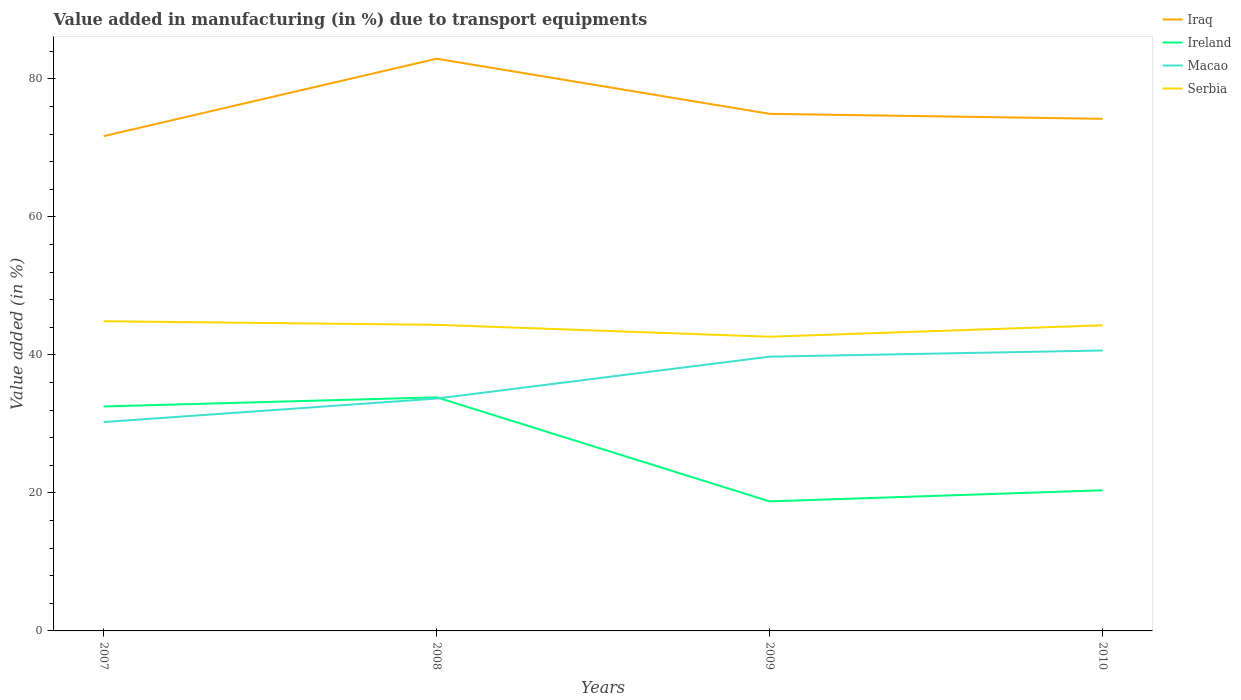How many different coloured lines are there?
Offer a terse response. 4. Is the number of lines equal to the number of legend labels?
Provide a succinct answer. Yes. Across all years, what is the maximum percentage of value added in manufacturing due to transport equipments in Macao?
Your answer should be very brief. 30.27. What is the total percentage of value added in manufacturing due to transport equipments in Ireland in the graph?
Provide a short and direct response. 15.08. What is the difference between the highest and the second highest percentage of value added in manufacturing due to transport equipments in Iraq?
Offer a terse response. 11.22. What is the difference between the highest and the lowest percentage of value added in manufacturing due to transport equipments in Macao?
Keep it short and to the point. 2. Is the percentage of value added in manufacturing due to transport equipments in Ireland strictly greater than the percentage of value added in manufacturing due to transport equipments in Serbia over the years?
Provide a short and direct response. Yes. How many lines are there?
Make the answer very short. 4. What is the difference between two consecutive major ticks on the Y-axis?
Your answer should be very brief. 20. Does the graph contain any zero values?
Ensure brevity in your answer.  No. Does the graph contain grids?
Offer a terse response. No. Where does the legend appear in the graph?
Give a very brief answer. Top right. How are the legend labels stacked?
Offer a terse response. Vertical. What is the title of the graph?
Ensure brevity in your answer.  Value added in manufacturing (in %) due to transport equipments. What is the label or title of the Y-axis?
Your answer should be compact. Value added (in %). What is the Value added (in %) of Iraq in 2007?
Your response must be concise. 71.71. What is the Value added (in %) of Ireland in 2007?
Provide a succinct answer. 32.53. What is the Value added (in %) of Macao in 2007?
Make the answer very short. 30.27. What is the Value added (in %) in Serbia in 2007?
Offer a terse response. 44.88. What is the Value added (in %) of Iraq in 2008?
Your answer should be compact. 82.93. What is the Value added (in %) in Ireland in 2008?
Your answer should be very brief. 33.86. What is the Value added (in %) of Macao in 2008?
Make the answer very short. 33.68. What is the Value added (in %) of Serbia in 2008?
Your answer should be very brief. 44.37. What is the Value added (in %) of Iraq in 2009?
Make the answer very short. 74.94. What is the Value added (in %) in Ireland in 2009?
Offer a very short reply. 18.77. What is the Value added (in %) of Macao in 2009?
Your answer should be compact. 39.75. What is the Value added (in %) of Serbia in 2009?
Offer a very short reply. 42.64. What is the Value added (in %) of Iraq in 2010?
Offer a very short reply. 74.22. What is the Value added (in %) of Ireland in 2010?
Your answer should be very brief. 20.38. What is the Value added (in %) in Macao in 2010?
Give a very brief answer. 40.65. What is the Value added (in %) of Serbia in 2010?
Provide a succinct answer. 44.29. Across all years, what is the maximum Value added (in %) of Iraq?
Provide a short and direct response. 82.93. Across all years, what is the maximum Value added (in %) of Ireland?
Your answer should be very brief. 33.86. Across all years, what is the maximum Value added (in %) of Macao?
Your answer should be very brief. 40.65. Across all years, what is the maximum Value added (in %) of Serbia?
Your answer should be compact. 44.88. Across all years, what is the minimum Value added (in %) in Iraq?
Ensure brevity in your answer.  71.71. Across all years, what is the minimum Value added (in %) of Ireland?
Offer a terse response. 18.77. Across all years, what is the minimum Value added (in %) in Macao?
Offer a very short reply. 30.27. Across all years, what is the minimum Value added (in %) in Serbia?
Keep it short and to the point. 42.64. What is the total Value added (in %) in Iraq in the graph?
Your response must be concise. 303.81. What is the total Value added (in %) of Ireland in the graph?
Offer a terse response. 105.54. What is the total Value added (in %) of Macao in the graph?
Provide a short and direct response. 144.35. What is the total Value added (in %) in Serbia in the graph?
Keep it short and to the point. 176.18. What is the difference between the Value added (in %) of Iraq in 2007 and that in 2008?
Ensure brevity in your answer.  -11.22. What is the difference between the Value added (in %) of Ireland in 2007 and that in 2008?
Keep it short and to the point. -1.32. What is the difference between the Value added (in %) in Macao in 2007 and that in 2008?
Your answer should be compact. -3.41. What is the difference between the Value added (in %) in Serbia in 2007 and that in 2008?
Your answer should be compact. 0.51. What is the difference between the Value added (in %) in Iraq in 2007 and that in 2009?
Your answer should be very brief. -3.23. What is the difference between the Value added (in %) in Ireland in 2007 and that in 2009?
Your response must be concise. 13.76. What is the difference between the Value added (in %) in Macao in 2007 and that in 2009?
Provide a short and direct response. -9.48. What is the difference between the Value added (in %) in Serbia in 2007 and that in 2009?
Make the answer very short. 2.24. What is the difference between the Value added (in %) in Iraq in 2007 and that in 2010?
Your answer should be compact. -2.51. What is the difference between the Value added (in %) of Ireland in 2007 and that in 2010?
Provide a succinct answer. 12.15. What is the difference between the Value added (in %) of Macao in 2007 and that in 2010?
Keep it short and to the point. -10.38. What is the difference between the Value added (in %) of Serbia in 2007 and that in 2010?
Your answer should be compact. 0.59. What is the difference between the Value added (in %) in Iraq in 2008 and that in 2009?
Your answer should be very brief. 7.99. What is the difference between the Value added (in %) in Ireland in 2008 and that in 2009?
Offer a very short reply. 15.08. What is the difference between the Value added (in %) of Macao in 2008 and that in 2009?
Provide a succinct answer. -6.07. What is the difference between the Value added (in %) in Serbia in 2008 and that in 2009?
Offer a very short reply. 1.73. What is the difference between the Value added (in %) of Iraq in 2008 and that in 2010?
Ensure brevity in your answer.  8.71. What is the difference between the Value added (in %) of Ireland in 2008 and that in 2010?
Offer a terse response. 13.47. What is the difference between the Value added (in %) in Macao in 2008 and that in 2010?
Provide a succinct answer. -6.97. What is the difference between the Value added (in %) in Serbia in 2008 and that in 2010?
Make the answer very short. 0.07. What is the difference between the Value added (in %) in Iraq in 2009 and that in 2010?
Your answer should be compact. 0.72. What is the difference between the Value added (in %) in Ireland in 2009 and that in 2010?
Ensure brevity in your answer.  -1.61. What is the difference between the Value added (in %) in Macao in 2009 and that in 2010?
Your answer should be very brief. -0.9. What is the difference between the Value added (in %) in Serbia in 2009 and that in 2010?
Offer a very short reply. -1.66. What is the difference between the Value added (in %) of Iraq in 2007 and the Value added (in %) of Ireland in 2008?
Offer a terse response. 37.86. What is the difference between the Value added (in %) of Iraq in 2007 and the Value added (in %) of Macao in 2008?
Offer a terse response. 38.03. What is the difference between the Value added (in %) in Iraq in 2007 and the Value added (in %) in Serbia in 2008?
Give a very brief answer. 27.35. What is the difference between the Value added (in %) of Ireland in 2007 and the Value added (in %) of Macao in 2008?
Your answer should be compact. -1.15. What is the difference between the Value added (in %) in Ireland in 2007 and the Value added (in %) in Serbia in 2008?
Your answer should be compact. -11.83. What is the difference between the Value added (in %) in Macao in 2007 and the Value added (in %) in Serbia in 2008?
Your response must be concise. -14.1. What is the difference between the Value added (in %) of Iraq in 2007 and the Value added (in %) of Ireland in 2009?
Provide a short and direct response. 52.94. What is the difference between the Value added (in %) in Iraq in 2007 and the Value added (in %) in Macao in 2009?
Offer a terse response. 31.96. What is the difference between the Value added (in %) of Iraq in 2007 and the Value added (in %) of Serbia in 2009?
Offer a terse response. 29.07. What is the difference between the Value added (in %) in Ireland in 2007 and the Value added (in %) in Macao in 2009?
Your response must be concise. -7.22. What is the difference between the Value added (in %) in Ireland in 2007 and the Value added (in %) in Serbia in 2009?
Provide a short and direct response. -10.11. What is the difference between the Value added (in %) in Macao in 2007 and the Value added (in %) in Serbia in 2009?
Your response must be concise. -12.37. What is the difference between the Value added (in %) of Iraq in 2007 and the Value added (in %) of Ireland in 2010?
Provide a succinct answer. 51.33. What is the difference between the Value added (in %) of Iraq in 2007 and the Value added (in %) of Macao in 2010?
Provide a succinct answer. 31.07. What is the difference between the Value added (in %) of Iraq in 2007 and the Value added (in %) of Serbia in 2010?
Your response must be concise. 27.42. What is the difference between the Value added (in %) of Ireland in 2007 and the Value added (in %) of Macao in 2010?
Give a very brief answer. -8.11. What is the difference between the Value added (in %) of Ireland in 2007 and the Value added (in %) of Serbia in 2010?
Provide a succinct answer. -11.76. What is the difference between the Value added (in %) in Macao in 2007 and the Value added (in %) in Serbia in 2010?
Give a very brief answer. -14.02. What is the difference between the Value added (in %) in Iraq in 2008 and the Value added (in %) in Ireland in 2009?
Your answer should be compact. 64.16. What is the difference between the Value added (in %) of Iraq in 2008 and the Value added (in %) of Macao in 2009?
Make the answer very short. 43.18. What is the difference between the Value added (in %) in Iraq in 2008 and the Value added (in %) in Serbia in 2009?
Your answer should be compact. 40.29. What is the difference between the Value added (in %) in Ireland in 2008 and the Value added (in %) in Macao in 2009?
Offer a very short reply. -5.89. What is the difference between the Value added (in %) in Ireland in 2008 and the Value added (in %) in Serbia in 2009?
Provide a short and direct response. -8.78. What is the difference between the Value added (in %) in Macao in 2008 and the Value added (in %) in Serbia in 2009?
Provide a succinct answer. -8.96. What is the difference between the Value added (in %) in Iraq in 2008 and the Value added (in %) in Ireland in 2010?
Provide a succinct answer. 62.55. What is the difference between the Value added (in %) of Iraq in 2008 and the Value added (in %) of Macao in 2010?
Offer a very short reply. 42.29. What is the difference between the Value added (in %) of Iraq in 2008 and the Value added (in %) of Serbia in 2010?
Keep it short and to the point. 38.64. What is the difference between the Value added (in %) of Ireland in 2008 and the Value added (in %) of Macao in 2010?
Your answer should be compact. -6.79. What is the difference between the Value added (in %) of Ireland in 2008 and the Value added (in %) of Serbia in 2010?
Ensure brevity in your answer.  -10.44. What is the difference between the Value added (in %) of Macao in 2008 and the Value added (in %) of Serbia in 2010?
Give a very brief answer. -10.61. What is the difference between the Value added (in %) of Iraq in 2009 and the Value added (in %) of Ireland in 2010?
Provide a short and direct response. 54.56. What is the difference between the Value added (in %) of Iraq in 2009 and the Value added (in %) of Macao in 2010?
Keep it short and to the point. 34.3. What is the difference between the Value added (in %) of Iraq in 2009 and the Value added (in %) of Serbia in 2010?
Your answer should be very brief. 30.65. What is the difference between the Value added (in %) in Ireland in 2009 and the Value added (in %) in Macao in 2010?
Your answer should be very brief. -21.87. What is the difference between the Value added (in %) in Ireland in 2009 and the Value added (in %) in Serbia in 2010?
Keep it short and to the point. -25.52. What is the difference between the Value added (in %) in Macao in 2009 and the Value added (in %) in Serbia in 2010?
Your answer should be very brief. -4.54. What is the average Value added (in %) of Iraq per year?
Make the answer very short. 75.95. What is the average Value added (in %) in Ireland per year?
Your answer should be very brief. 26.39. What is the average Value added (in %) in Macao per year?
Offer a terse response. 36.09. What is the average Value added (in %) in Serbia per year?
Ensure brevity in your answer.  44.04. In the year 2007, what is the difference between the Value added (in %) in Iraq and Value added (in %) in Ireland?
Offer a terse response. 39.18. In the year 2007, what is the difference between the Value added (in %) in Iraq and Value added (in %) in Macao?
Make the answer very short. 41.44. In the year 2007, what is the difference between the Value added (in %) in Iraq and Value added (in %) in Serbia?
Offer a terse response. 26.83. In the year 2007, what is the difference between the Value added (in %) of Ireland and Value added (in %) of Macao?
Your answer should be compact. 2.26. In the year 2007, what is the difference between the Value added (in %) of Ireland and Value added (in %) of Serbia?
Keep it short and to the point. -12.35. In the year 2007, what is the difference between the Value added (in %) of Macao and Value added (in %) of Serbia?
Give a very brief answer. -14.61. In the year 2008, what is the difference between the Value added (in %) in Iraq and Value added (in %) in Ireland?
Give a very brief answer. 49.08. In the year 2008, what is the difference between the Value added (in %) of Iraq and Value added (in %) of Macao?
Keep it short and to the point. 49.25. In the year 2008, what is the difference between the Value added (in %) of Iraq and Value added (in %) of Serbia?
Offer a terse response. 38.57. In the year 2008, what is the difference between the Value added (in %) of Ireland and Value added (in %) of Macao?
Your answer should be very brief. 0.18. In the year 2008, what is the difference between the Value added (in %) in Ireland and Value added (in %) in Serbia?
Keep it short and to the point. -10.51. In the year 2008, what is the difference between the Value added (in %) in Macao and Value added (in %) in Serbia?
Offer a terse response. -10.69. In the year 2009, what is the difference between the Value added (in %) of Iraq and Value added (in %) of Ireland?
Provide a short and direct response. 56.17. In the year 2009, what is the difference between the Value added (in %) in Iraq and Value added (in %) in Macao?
Keep it short and to the point. 35.19. In the year 2009, what is the difference between the Value added (in %) of Iraq and Value added (in %) of Serbia?
Your answer should be very brief. 32.3. In the year 2009, what is the difference between the Value added (in %) in Ireland and Value added (in %) in Macao?
Give a very brief answer. -20.98. In the year 2009, what is the difference between the Value added (in %) of Ireland and Value added (in %) of Serbia?
Provide a succinct answer. -23.87. In the year 2009, what is the difference between the Value added (in %) of Macao and Value added (in %) of Serbia?
Your answer should be very brief. -2.89. In the year 2010, what is the difference between the Value added (in %) of Iraq and Value added (in %) of Ireland?
Offer a very short reply. 53.84. In the year 2010, what is the difference between the Value added (in %) of Iraq and Value added (in %) of Macao?
Keep it short and to the point. 33.58. In the year 2010, what is the difference between the Value added (in %) of Iraq and Value added (in %) of Serbia?
Give a very brief answer. 29.93. In the year 2010, what is the difference between the Value added (in %) of Ireland and Value added (in %) of Macao?
Offer a terse response. -20.26. In the year 2010, what is the difference between the Value added (in %) of Ireland and Value added (in %) of Serbia?
Offer a very short reply. -23.91. In the year 2010, what is the difference between the Value added (in %) in Macao and Value added (in %) in Serbia?
Keep it short and to the point. -3.65. What is the ratio of the Value added (in %) in Iraq in 2007 to that in 2008?
Provide a short and direct response. 0.86. What is the ratio of the Value added (in %) in Ireland in 2007 to that in 2008?
Give a very brief answer. 0.96. What is the ratio of the Value added (in %) in Macao in 2007 to that in 2008?
Your response must be concise. 0.9. What is the ratio of the Value added (in %) of Serbia in 2007 to that in 2008?
Provide a succinct answer. 1.01. What is the ratio of the Value added (in %) of Iraq in 2007 to that in 2009?
Give a very brief answer. 0.96. What is the ratio of the Value added (in %) in Ireland in 2007 to that in 2009?
Your response must be concise. 1.73. What is the ratio of the Value added (in %) of Macao in 2007 to that in 2009?
Provide a succinct answer. 0.76. What is the ratio of the Value added (in %) of Serbia in 2007 to that in 2009?
Provide a succinct answer. 1.05. What is the ratio of the Value added (in %) in Iraq in 2007 to that in 2010?
Keep it short and to the point. 0.97. What is the ratio of the Value added (in %) of Ireland in 2007 to that in 2010?
Ensure brevity in your answer.  1.6. What is the ratio of the Value added (in %) of Macao in 2007 to that in 2010?
Give a very brief answer. 0.74. What is the ratio of the Value added (in %) in Serbia in 2007 to that in 2010?
Offer a very short reply. 1.01. What is the ratio of the Value added (in %) of Iraq in 2008 to that in 2009?
Give a very brief answer. 1.11. What is the ratio of the Value added (in %) in Ireland in 2008 to that in 2009?
Keep it short and to the point. 1.8. What is the ratio of the Value added (in %) of Macao in 2008 to that in 2009?
Provide a succinct answer. 0.85. What is the ratio of the Value added (in %) in Serbia in 2008 to that in 2009?
Provide a succinct answer. 1.04. What is the ratio of the Value added (in %) in Iraq in 2008 to that in 2010?
Offer a terse response. 1.12. What is the ratio of the Value added (in %) in Ireland in 2008 to that in 2010?
Offer a very short reply. 1.66. What is the ratio of the Value added (in %) of Macao in 2008 to that in 2010?
Your answer should be very brief. 0.83. What is the ratio of the Value added (in %) in Iraq in 2009 to that in 2010?
Ensure brevity in your answer.  1.01. What is the ratio of the Value added (in %) of Ireland in 2009 to that in 2010?
Give a very brief answer. 0.92. What is the ratio of the Value added (in %) in Serbia in 2009 to that in 2010?
Give a very brief answer. 0.96. What is the difference between the highest and the second highest Value added (in %) in Iraq?
Ensure brevity in your answer.  7.99. What is the difference between the highest and the second highest Value added (in %) in Ireland?
Offer a terse response. 1.32. What is the difference between the highest and the second highest Value added (in %) in Macao?
Give a very brief answer. 0.9. What is the difference between the highest and the second highest Value added (in %) in Serbia?
Ensure brevity in your answer.  0.51. What is the difference between the highest and the lowest Value added (in %) of Iraq?
Offer a very short reply. 11.22. What is the difference between the highest and the lowest Value added (in %) in Ireland?
Make the answer very short. 15.08. What is the difference between the highest and the lowest Value added (in %) of Macao?
Your answer should be compact. 10.38. What is the difference between the highest and the lowest Value added (in %) in Serbia?
Give a very brief answer. 2.24. 